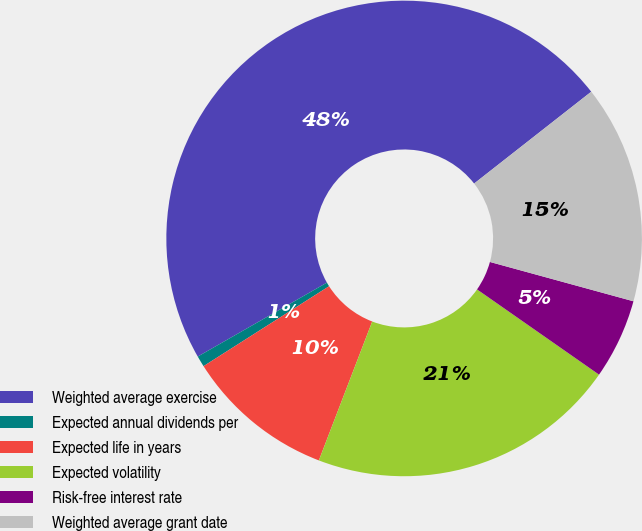Convert chart to OTSL. <chart><loc_0><loc_0><loc_500><loc_500><pie_chart><fcel>Weighted average exercise<fcel>Expected annual dividends per<fcel>Expected life in years<fcel>Expected volatility<fcel>Risk-free interest rate<fcel>Weighted average grant date<nl><fcel>47.69%<fcel>0.75%<fcel>10.14%<fcel>21.13%<fcel>5.45%<fcel>14.84%<nl></chart> 